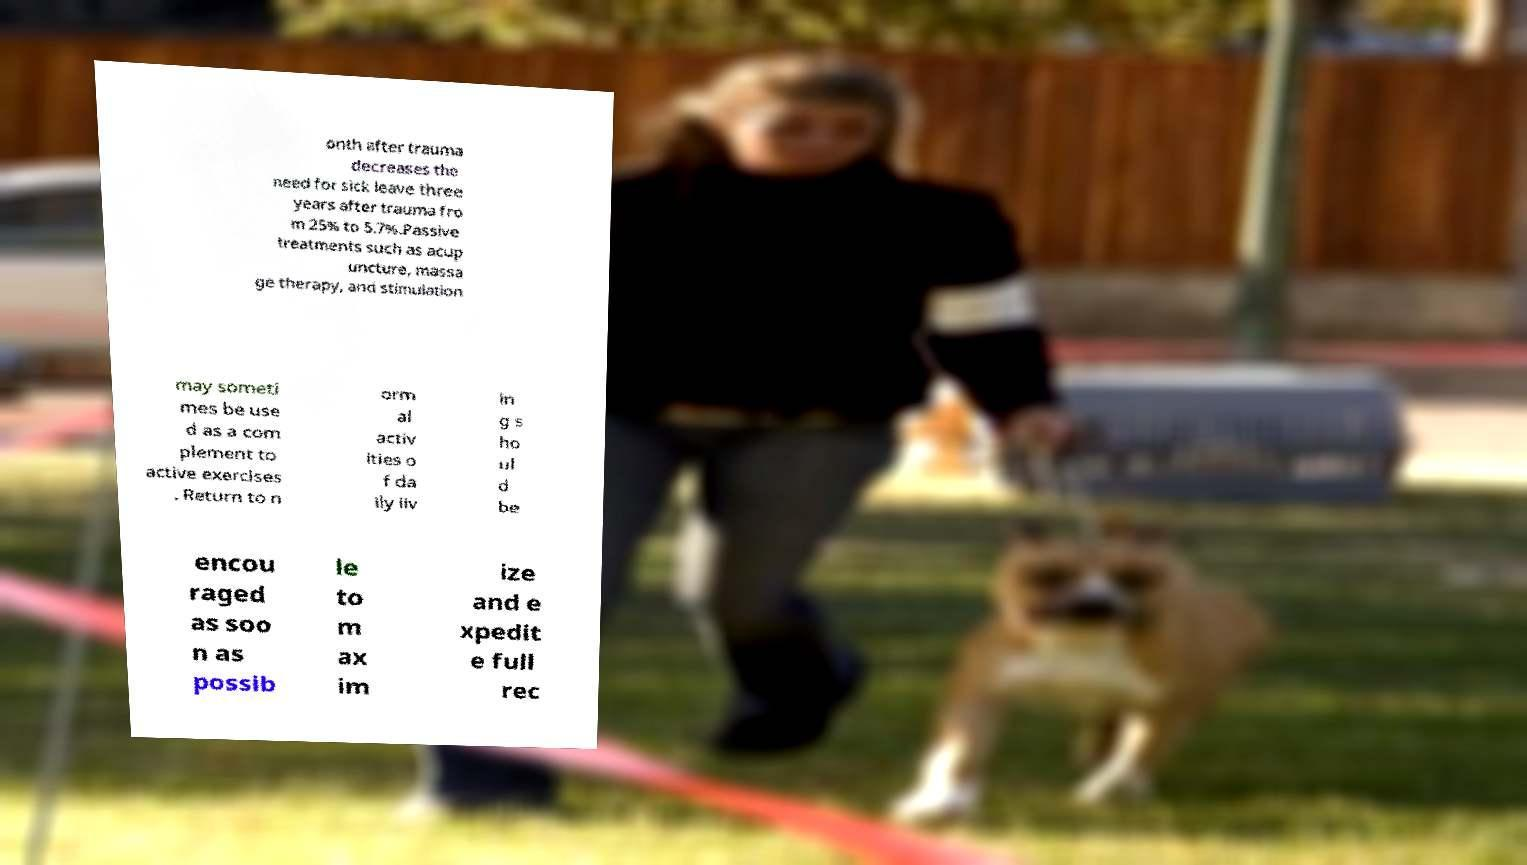For documentation purposes, I need the text within this image transcribed. Could you provide that? onth after trauma decreases the need for sick leave three years after trauma fro m 25% to 5.7%.Passive treatments such as acup uncture, massa ge therapy, and stimulation may someti mes be use d as a com plement to active exercises . Return to n orm al activ ities o f da ily liv in g s ho ul d be encou raged as soo n as possib le to m ax im ize and e xpedit e full rec 